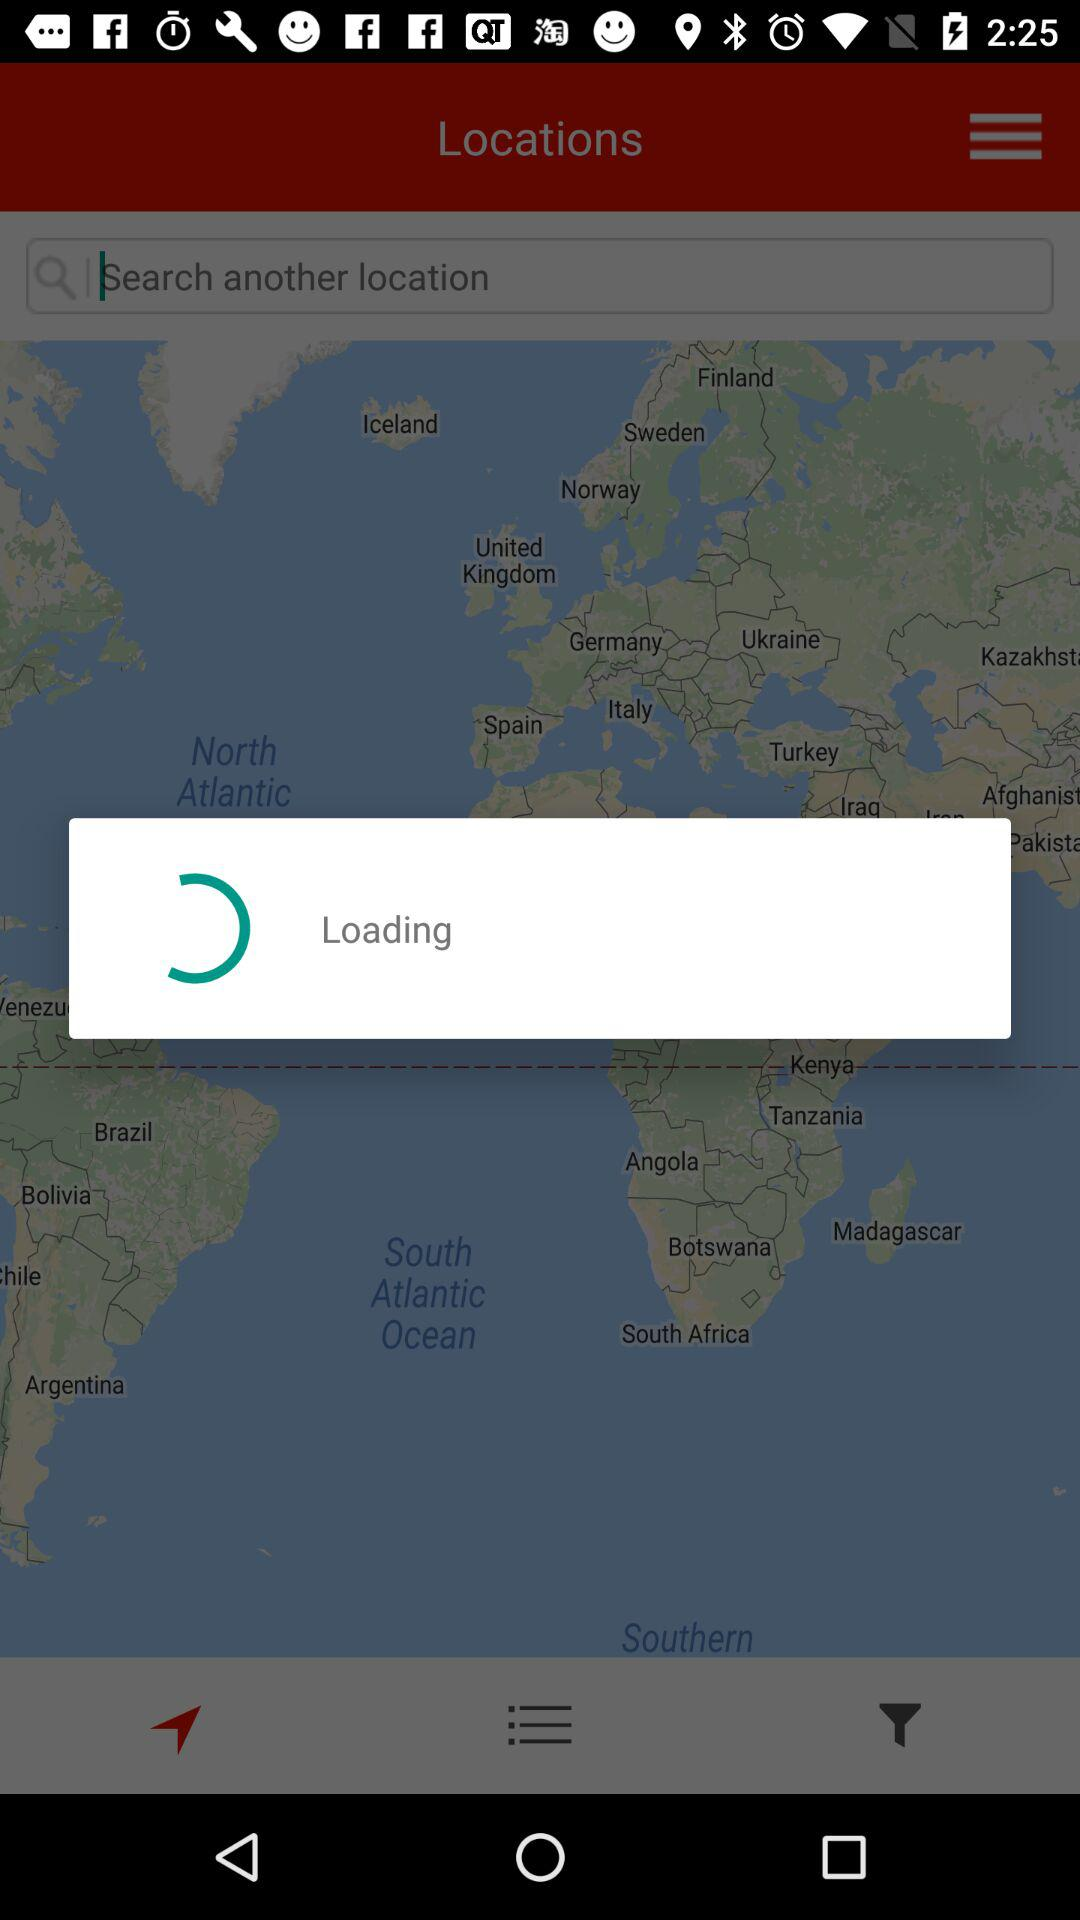What date is selected? The selected date is March 21, 2017. 